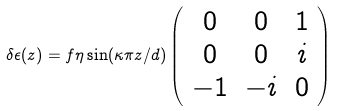Convert formula to latex. <formula><loc_0><loc_0><loc_500><loc_500>\delta { \epsilon } ( z ) = f \eta \sin ( \kappa \pi z / d ) \left ( \begin{array} { c c c } 0 & 0 & 1 \\ 0 & 0 & i \\ - 1 & - i & 0 \end{array} \right ) \,</formula> 